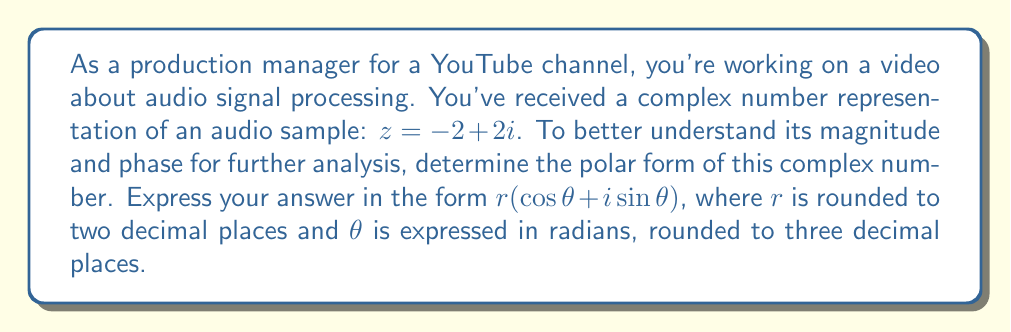Teach me how to tackle this problem. To convert a complex number from rectangular form $(a + bi)$ to polar form $r(\cos\theta + i\sin\theta)$, we need to follow these steps:

1. Calculate the magnitude $r$:
   $$r = \sqrt{a^2 + b^2}$$
   Here, $a = -2$ and $b = 2$
   $$r = \sqrt{(-2)^2 + 2^2} = \sqrt{4 + 4} = \sqrt{8} = 2\sqrt{2} \approx 2.83$$

2. Calculate the angle $\theta$:
   $$\theta = \arctan(\frac{b}{a})$$
   However, since $a$ is negative and $b$ is positive, we need to add $\pi$ to the result:
   $$\theta = \arctan(\frac{2}{-2}) + \pi = -\frac{\pi}{4} + \pi = \frac{3\pi}{4} \approx 2.356$$

3. Express the complex number in polar form:
   $$z = r(\cos\theta + i\sin\theta)$$

Substituting our calculated values:
$$z \approx 2.83(\cos(2.356) + i\sin(2.356))$$

This polar form representation provides important information for audio signal analysis:
- The magnitude (2.83) represents the amplitude of the signal.
- The angle (2.356 radians or 135 degrees) represents the phase of the signal.
Answer: $2.83(\cos(2.356) + i\sin(2.356))$ 